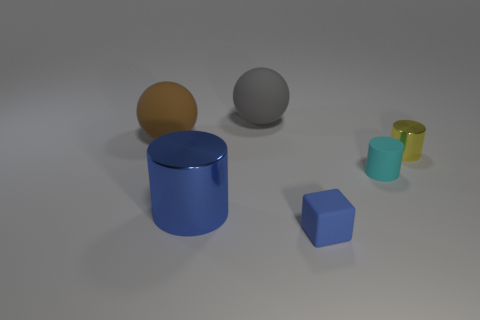What number of objects are brown rubber spheres or purple metal objects?
Give a very brief answer. 1. What size is the blue object that is the same shape as the small yellow metal object?
Offer a very short reply. Large. Are there more tiny yellow shiny things right of the small yellow object than large things?
Give a very brief answer. No. Is the material of the cyan object the same as the brown sphere?
Provide a succinct answer. Yes. How many objects are big things that are behind the tiny yellow metal cylinder or small yellow cylinders that are behind the tiny cyan cylinder?
Ensure brevity in your answer.  3. What is the color of the other tiny thing that is the same shape as the tiny cyan rubber thing?
Provide a short and direct response. Yellow. How many tiny shiny cubes have the same color as the large cylinder?
Make the answer very short. 0. Do the large cylinder and the rubber cylinder have the same color?
Your response must be concise. No. How many things are either matte balls that are behind the big brown ball or tiny blue rubber cubes?
Offer a very short reply. 2. What is the color of the shiny cylinder on the left side of the shiny cylinder that is behind the blue thing left of the tiny blue matte cube?
Offer a very short reply. Blue. 